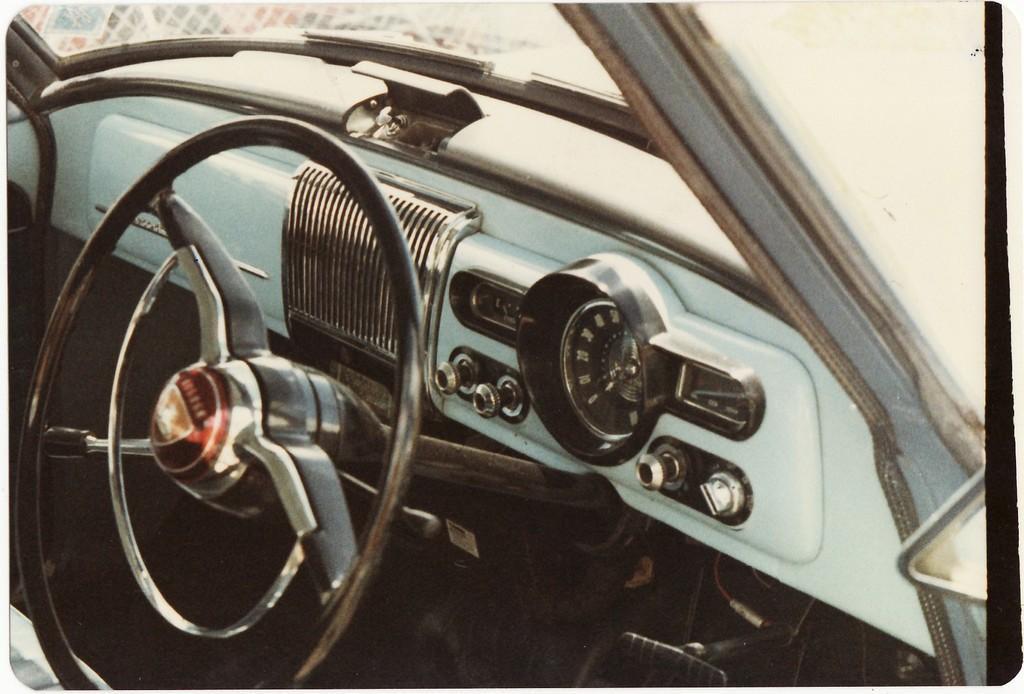Please provide a concise description of this image. This picture is of a car. There is a car steering. 